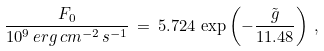Convert formula to latex. <formula><loc_0><loc_0><loc_500><loc_500>\frac { F _ { 0 } } { 1 0 ^ { 9 } \, e r g \, c m ^ { - 2 } \, s ^ { - 1 } } \, = \, 5 . 7 2 4 \, \exp \left ( - \frac { \tilde { g } } { 1 1 . 4 8 } \right ) \, ,</formula> 